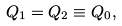<formula> <loc_0><loc_0><loc_500><loc_500>Q _ { 1 } = Q _ { 2 } \equiv Q _ { 0 } ,</formula> 